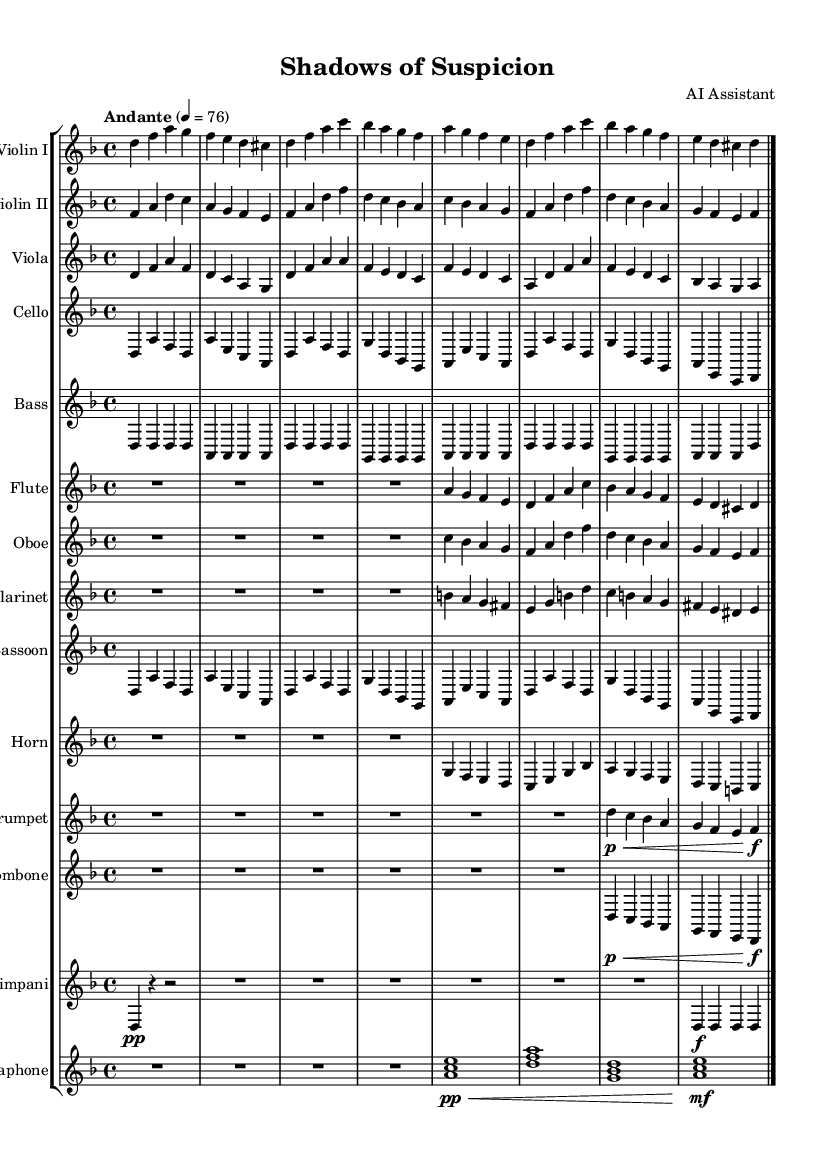What is the key signature of this music? The key signature is D minor, indicated by the presence of one flat (B flat) in the key signature section at the beginning of the piece.
Answer: D minor What is the time signature of this music? The time signature is 4/4, which is shown at the beginning of the score, indicating that there are four beats per measure.
Answer: 4/4 What is the tempo marking of this music? The tempo marking is "Andante," which is indicated above the staff and typically denotes a moderately slow tempo.
Answer: Andante Which instruments are part of this symphony? The symphony includes strings (violins, viola, cello, bass), woodwinds (flute, oboe, clarinet, bassoon), brass (horn, trumpet, trombone), percussion (timpani), and vibraphone, evident from the different staves and instrument names listed at the beginning of the score.
Answer: Violin I, Violin II, Viola, Cello, Bass, Flute, Oboe, Clarinet, Bassoon, Horn, Trumpet, Trombone, Timpani, Vibraphone How many measures are there in the piece? The piece consists of 8 measures, counted directly from the notation in the staves, where each measure is separated by vertical bar lines.
Answer: 8 measures What type of musical work is this? This piece is classified as a symphony due to its orchestral scoring, structure, and the dramatic character typical of symphonic compositions, particularly those evoking noir atmosphere.
Answer: Symphony 